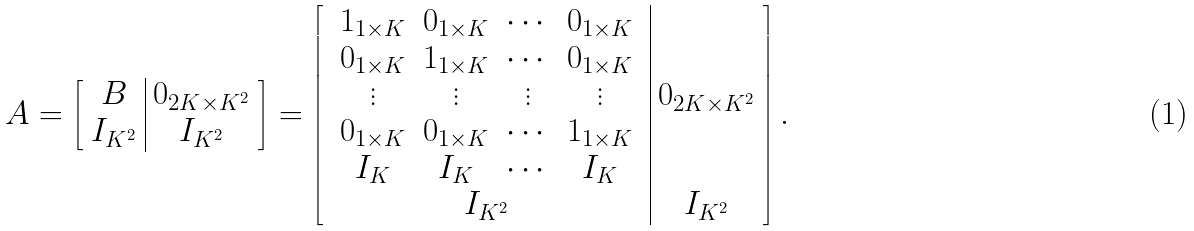<formula> <loc_0><loc_0><loc_500><loc_500>A = \left [ \begin{array} { c | c } B & 0 _ { 2 K \times K ^ { 2 } } \\ I _ { K ^ { 2 } } & I _ { K ^ { 2 } } \\ \end{array} \right ] = \left [ \begin{array} { c | c } \begin{array} { c c c c } 1 _ { 1 \times K } & 0 _ { 1 \times K } & \cdots & 0 _ { 1 \times K } \\ 0 _ { 1 \times K } & 1 _ { 1 \times K } & \cdots & 0 _ { 1 \times K } \\ \vdots & \vdots & \vdots & \vdots \\ 0 _ { 1 \times K } & 0 _ { 1 \times K } & \cdots & 1 _ { 1 \times K } \\ I _ { K } & I _ { K } & \cdots & I _ { K } \end{array} & 0 _ { 2 K \times K ^ { 2 } } \\ I _ { K ^ { 2 } } & I _ { K ^ { 2 } } \\ \end{array} \right ] .</formula> 